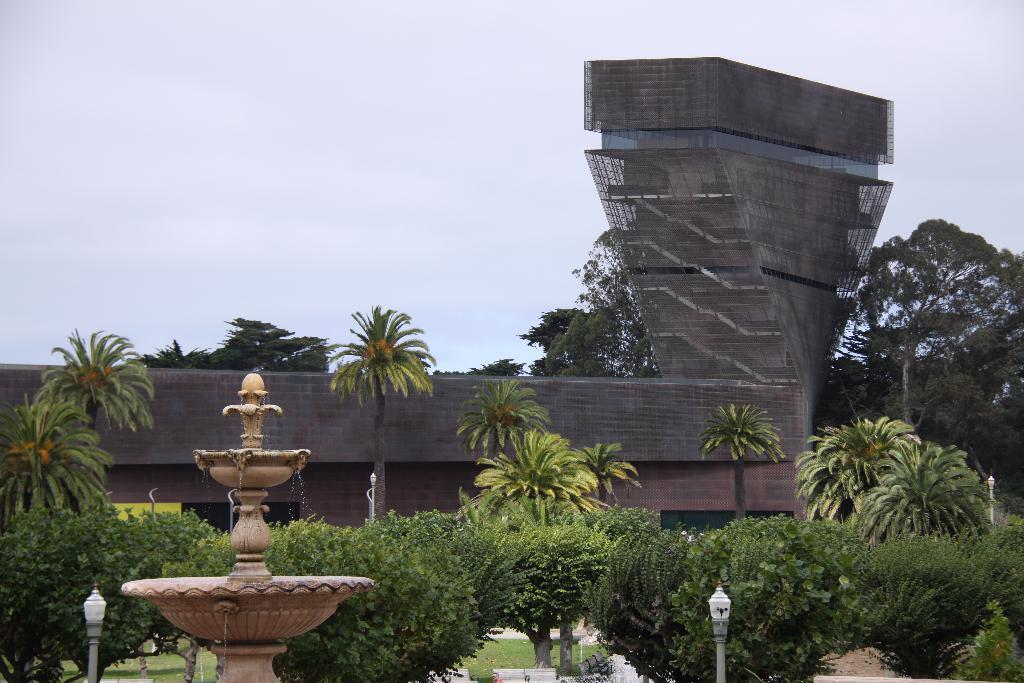Please provide a concise description of this image. In the foreground, I can see a fountain, grass, plants, trees and poles. In the background, I can see a building and the sky. This picture might be taken in a day. 